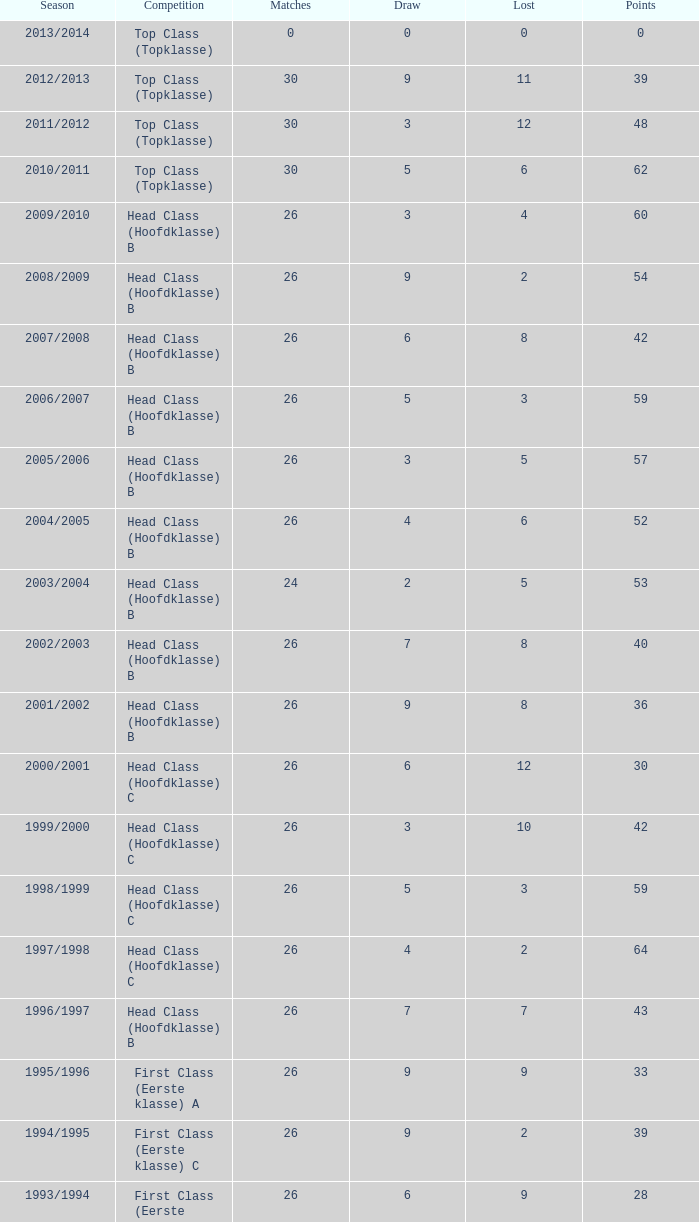Can you give me this table as a dict? {'header': ['Season', 'Competition', 'Matches', 'Draw', 'Lost', 'Points'], 'rows': [['2013/2014', 'Top Class (Topklasse)', '0', '0', '0', '0'], ['2012/2013', 'Top Class (Topklasse)', '30', '9', '11', '39'], ['2011/2012', 'Top Class (Topklasse)', '30', '3', '12', '48'], ['2010/2011', 'Top Class (Topklasse)', '30', '5', '6', '62'], ['2009/2010', 'Head Class (Hoofdklasse) B', '26', '3', '4', '60'], ['2008/2009', 'Head Class (Hoofdklasse) B', '26', '9', '2', '54'], ['2007/2008', 'Head Class (Hoofdklasse) B', '26', '6', '8', '42'], ['2006/2007', 'Head Class (Hoofdklasse) B', '26', '5', '3', '59'], ['2005/2006', 'Head Class (Hoofdklasse) B', '26', '3', '5', '57'], ['2004/2005', 'Head Class (Hoofdklasse) B', '26', '4', '6', '52'], ['2003/2004', 'Head Class (Hoofdklasse) B', '24', '2', '5', '53'], ['2002/2003', 'Head Class (Hoofdklasse) B', '26', '7', '8', '40'], ['2001/2002', 'Head Class (Hoofdklasse) B', '26', '9', '8', '36'], ['2000/2001', 'Head Class (Hoofdklasse) C', '26', '6', '12', '30'], ['1999/2000', 'Head Class (Hoofdklasse) C', '26', '3', '10', '42'], ['1998/1999', 'Head Class (Hoofdklasse) C', '26', '5', '3', '59'], ['1997/1998', 'Head Class (Hoofdklasse) C', '26', '4', '2', '64'], ['1996/1997', 'Head Class (Hoofdklasse) B', '26', '7', '7', '43'], ['1995/1996', 'First Class (Eerste klasse) A', '26', '9', '9', '33'], ['1994/1995', 'First Class (Eerste klasse) C', '26', '9', '2', '39'], ['1993/1994', 'First Class (Eerste klasse) B', '26', '6', '9', '28'], ['1992/1993', 'First Class (Eerste klasse) B', '26', '3', '11', '27'], ['1991/1992', 'First Class (Eerste klasse) B', '26', '7', '6', '33'], ['1990/1991', 'First Class (Eerste klasse) A', '26', '9', '5', '33'], ['1989/1990', 'First Class (Eerste klasse) B', '26', '7', '10', '25'], ['1988/1989', 'First Class (Eerste klasse)B', '26', '6', '9', '28'], ['1987/1988', 'First Class (Eerste klasse) A', '26', '5', '4', '39'], ['1986/1987', 'First Class (Eerste klasse) B', '26', '6', '6', '34'], ['1985/1986', 'First Class (Eerste klasse) B', '26', '7', '3', '39'], ['1984/1985', 'First Class (Eerste klasse) B', '26', '6', '9', '28'], ['1983/1984', 'First Class (Eerste klasse) C', '26', '5', '3', '37'], ['1982/1983', 'First Class (Eerste klasse) B', '26', '10', '1', '40'], ['1981/1982', 'First Class (Eerste klasse) B', '26', '8', '3', '38'], ['1980/1981', 'First Class (Eerste klasse) A', '26', '5', '10', '27'], ['1979/1980', 'First Class (Eerste klasse) B', '26', '6', '9', '28'], ['1978/1979', 'First Class (Eerste klasse) A', '26', '7', '6', '33'], ['1977/1978', 'First Class (Eerste klasse) A', '26', '6', '8', '30'], ['1976/1977', 'First Class (Eerste klasse) B', '26', '7', '3', '39'], ['1975/1976', 'First Class (Eerste klasse)B', '26', '5', '3', '41'], ['1974/1975', 'First Class (Eerste klasse) B', '26', '5', '5', '37'], ['1973/1974', 'First Class (Eerste klasse)A', '22', '6', '4', '30'], ['1972/1973', 'First Class (Eerste klasse) B', '22', '4', '2', '36'], ['1971/1972', 'First Class (Eerste klasse) B', '20', '3', '4', '29'], ['1970/1971', 'First Class (Eerste klasse) A', '18', '6', '4', '24']]} During the 2008/2009 season, what is the complete sum of match-ups with a setback less than 5 and a deadlock more than 9? 0.0. 